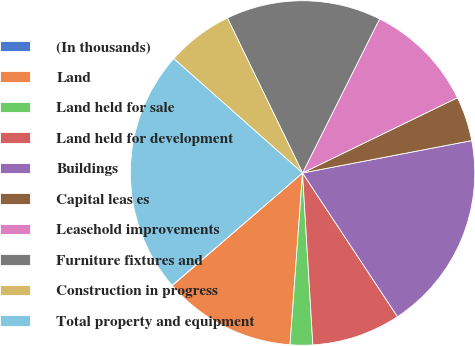Convert chart. <chart><loc_0><loc_0><loc_500><loc_500><pie_chart><fcel>(In thousands)<fcel>Land<fcel>Land held for sale<fcel>Land held for development<fcel>Buildings<fcel>Capital leas es<fcel>Leasehold improvements<fcel>Furniture fixtures and<fcel>Construction in progress<fcel>Total property and equipment<nl><fcel>0.04%<fcel>12.49%<fcel>2.11%<fcel>8.34%<fcel>18.72%<fcel>4.19%<fcel>10.42%<fcel>14.57%<fcel>6.26%<fcel>22.87%<nl></chart> 